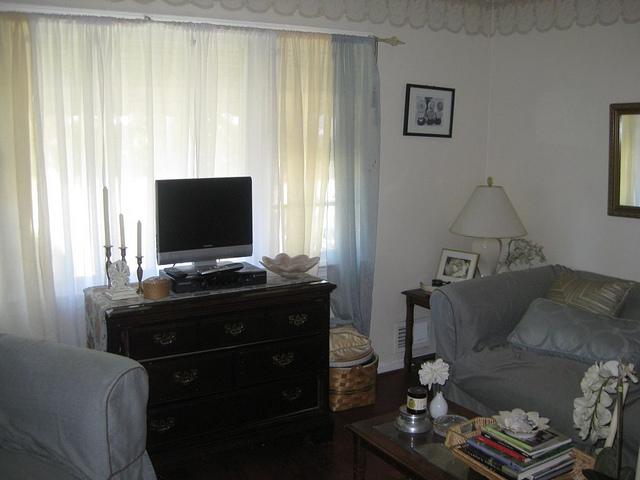How many people are in the scene?
Answer briefly. 0. What color are the curtains?
Be succinct. White. Is the mattress visible?
Quick response, please. No. How many candles are there?
Short answer required. 3. Is the lamp on?
Quick response, please. No. What room of a house is this?
Answer briefly. Living room. Are any of the lights on?
Be succinct. No. Is the light off?
Keep it brief. Yes. What material is the top of the table made of?
Be succinct. Glass. Is there a lampshade on the lamp?
Give a very brief answer. Yes. 